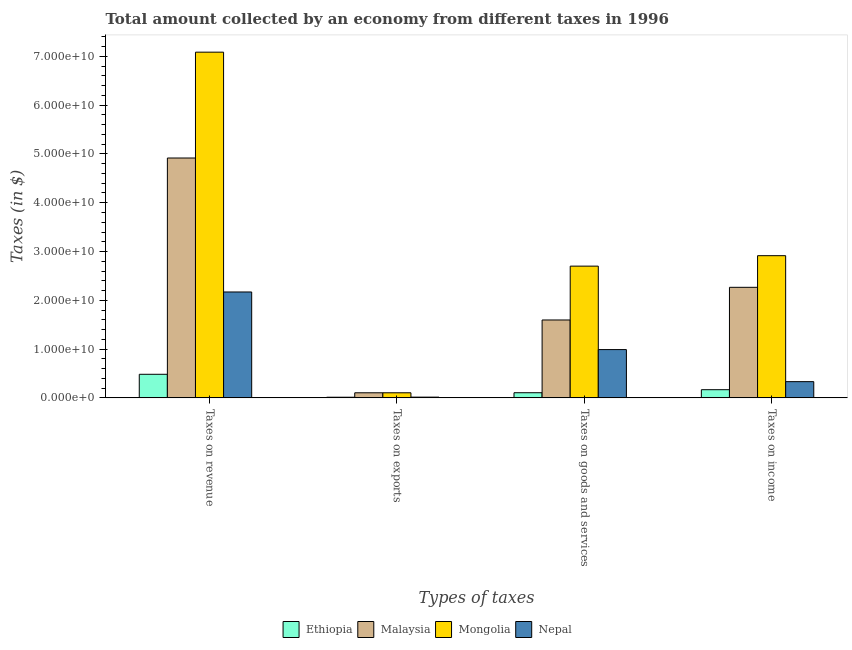Are the number of bars per tick equal to the number of legend labels?
Provide a short and direct response. Yes. How many bars are there on the 1st tick from the right?
Keep it short and to the point. 4. What is the label of the 4th group of bars from the left?
Provide a short and direct response. Taxes on income. What is the amount collected as tax on revenue in Nepal?
Provide a short and direct response. 2.17e+1. Across all countries, what is the maximum amount collected as tax on income?
Provide a short and direct response. 2.91e+1. Across all countries, what is the minimum amount collected as tax on revenue?
Provide a short and direct response. 4.84e+09. In which country was the amount collected as tax on goods maximum?
Your response must be concise. Mongolia. In which country was the amount collected as tax on income minimum?
Provide a short and direct response. Ethiopia. What is the total amount collected as tax on goods in the graph?
Keep it short and to the point. 5.39e+1. What is the difference between the amount collected as tax on exports in Mongolia and that in Ethiopia?
Ensure brevity in your answer.  9.12e+08. What is the difference between the amount collected as tax on exports in Nepal and the amount collected as tax on income in Malaysia?
Provide a succinct answer. -2.25e+1. What is the average amount collected as tax on goods per country?
Offer a terse response. 1.35e+1. What is the difference between the amount collected as tax on revenue and amount collected as tax on exports in Malaysia?
Make the answer very short. 4.81e+1. In how many countries, is the amount collected as tax on goods greater than 62000000000 $?
Offer a terse response. 0. What is the ratio of the amount collected as tax on exports in Ethiopia to that in Nepal?
Your answer should be compact. 0.87. Is the amount collected as tax on goods in Malaysia less than that in Nepal?
Offer a very short reply. No. What is the difference between the highest and the second highest amount collected as tax on revenue?
Provide a short and direct response. 2.17e+1. What is the difference between the highest and the lowest amount collected as tax on exports?
Your answer should be compact. 9.12e+08. In how many countries, is the amount collected as tax on goods greater than the average amount collected as tax on goods taken over all countries?
Make the answer very short. 2. What does the 4th bar from the left in Taxes on goods and services represents?
Offer a very short reply. Nepal. What does the 1st bar from the right in Taxes on revenue represents?
Make the answer very short. Nepal. How many bars are there?
Give a very brief answer. 16. Are all the bars in the graph horizontal?
Provide a short and direct response. No. How many countries are there in the graph?
Offer a terse response. 4. Are the values on the major ticks of Y-axis written in scientific E-notation?
Ensure brevity in your answer.  Yes. Does the graph contain any zero values?
Your answer should be very brief. No. Does the graph contain grids?
Offer a terse response. No. How many legend labels are there?
Your response must be concise. 4. How are the legend labels stacked?
Keep it short and to the point. Horizontal. What is the title of the graph?
Keep it short and to the point. Total amount collected by an economy from different taxes in 1996. What is the label or title of the X-axis?
Give a very brief answer. Types of taxes. What is the label or title of the Y-axis?
Your answer should be very brief. Taxes (in $). What is the Taxes (in $) of Ethiopia in Taxes on revenue?
Provide a succinct answer. 4.84e+09. What is the Taxes (in $) in Malaysia in Taxes on revenue?
Provide a short and direct response. 4.92e+1. What is the Taxes (in $) in Mongolia in Taxes on revenue?
Offer a terse response. 7.09e+1. What is the Taxes (in $) of Nepal in Taxes on revenue?
Make the answer very short. 2.17e+1. What is the Taxes (in $) in Ethiopia in Taxes on exports?
Your response must be concise. 1.31e+08. What is the Taxes (in $) in Malaysia in Taxes on exports?
Make the answer very short. 1.04e+09. What is the Taxes (in $) of Mongolia in Taxes on exports?
Your response must be concise. 1.04e+09. What is the Taxes (in $) in Nepal in Taxes on exports?
Ensure brevity in your answer.  1.50e+08. What is the Taxes (in $) in Ethiopia in Taxes on goods and services?
Your answer should be compact. 1.05e+09. What is the Taxes (in $) of Malaysia in Taxes on goods and services?
Your answer should be very brief. 1.60e+1. What is the Taxes (in $) in Mongolia in Taxes on goods and services?
Make the answer very short. 2.70e+1. What is the Taxes (in $) of Nepal in Taxes on goods and services?
Provide a short and direct response. 9.90e+09. What is the Taxes (in $) of Ethiopia in Taxes on income?
Provide a short and direct response. 1.68e+09. What is the Taxes (in $) of Malaysia in Taxes on income?
Give a very brief answer. 2.27e+1. What is the Taxes (in $) in Mongolia in Taxes on income?
Keep it short and to the point. 2.91e+1. What is the Taxes (in $) in Nepal in Taxes on income?
Keep it short and to the point. 3.33e+09. Across all Types of taxes, what is the maximum Taxes (in $) in Ethiopia?
Make the answer very short. 4.84e+09. Across all Types of taxes, what is the maximum Taxes (in $) in Malaysia?
Provide a succinct answer. 4.92e+1. Across all Types of taxes, what is the maximum Taxes (in $) of Mongolia?
Your answer should be very brief. 7.09e+1. Across all Types of taxes, what is the maximum Taxes (in $) of Nepal?
Keep it short and to the point. 2.17e+1. Across all Types of taxes, what is the minimum Taxes (in $) in Ethiopia?
Your answer should be compact. 1.31e+08. Across all Types of taxes, what is the minimum Taxes (in $) of Malaysia?
Offer a very short reply. 1.04e+09. Across all Types of taxes, what is the minimum Taxes (in $) in Mongolia?
Ensure brevity in your answer.  1.04e+09. Across all Types of taxes, what is the minimum Taxes (in $) in Nepal?
Your answer should be very brief. 1.50e+08. What is the total Taxes (in $) of Ethiopia in the graph?
Your answer should be compact. 7.70e+09. What is the total Taxes (in $) in Malaysia in the graph?
Ensure brevity in your answer.  8.88e+1. What is the total Taxes (in $) in Mongolia in the graph?
Offer a terse response. 1.28e+11. What is the total Taxes (in $) of Nepal in the graph?
Offer a terse response. 3.51e+1. What is the difference between the Taxes (in $) of Ethiopia in Taxes on revenue and that in Taxes on exports?
Keep it short and to the point. 4.70e+09. What is the difference between the Taxes (in $) in Malaysia in Taxes on revenue and that in Taxes on exports?
Keep it short and to the point. 4.81e+1. What is the difference between the Taxes (in $) in Mongolia in Taxes on revenue and that in Taxes on exports?
Keep it short and to the point. 6.98e+1. What is the difference between the Taxes (in $) of Nepal in Taxes on revenue and that in Taxes on exports?
Keep it short and to the point. 2.16e+1. What is the difference between the Taxes (in $) of Ethiopia in Taxes on revenue and that in Taxes on goods and services?
Your response must be concise. 3.78e+09. What is the difference between the Taxes (in $) of Malaysia in Taxes on revenue and that in Taxes on goods and services?
Your answer should be very brief. 3.32e+1. What is the difference between the Taxes (in $) of Mongolia in Taxes on revenue and that in Taxes on goods and services?
Ensure brevity in your answer.  4.39e+1. What is the difference between the Taxes (in $) in Nepal in Taxes on revenue and that in Taxes on goods and services?
Provide a short and direct response. 1.18e+1. What is the difference between the Taxes (in $) of Ethiopia in Taxes on revenue and that in Taxes on income?
Provide a succinct answer. 3.16e+09. What is the difference between the Taxes (in $) of Malaysia in Taxes on revenue and that in Taxes on income?
Your answer should be very brief. 2.65e+1. What is the difference between the Taxes (in $) in Mongolia in Taxes on revenue and that in Taxes on income?
Keep it short and to the point. 4.17e+1. What is the difference between the Taxes (in $) of Nepal in Taxes on revenue and that in Taxes on income?
Provide a short and direct response. 1.84e+1. What is the difference between the Taxes (in $) in Ethiopia in Taxes on exports and that in Taxes on goods and services?
Make the answer very short. -9.22e+08. What is the difference between the Taxes (in $) in Malaysia in Taxes on exports and that in Taxes on goods and services?
Make the answer very short. -1.49e+1. What is the difference between the Taxes (in $) of Mongolia in Taxes on exports and that in Taxes on goods and services?
Provide a succinct answer. -2.60e+1. What is the difference between the Taxes (in $) of Nepal in Taxes on exports and that in Taxes on goods and services?
Your answer should be compact. -9.75e+09. What is the difference between the Taxes (in $) of Ethiopia in Taxes on exports and that in Taxes on income?
Make the answer very short. -1.55e+09. What is the difference between the Taxes (in $) of Malaysia in Taxes on exports and that in Taxes on income?
Offer a terse response. -2.16e+1. What is the difference between the Taxes (in $) in Mongolia in Taxes on exports and that in Taxes on income?
Your response must be concise. -2.81e+1. What is the difference between the Taxes (in $) in Nepal in Taxes on exports and that in Taxes on income?
Ensure brevity in your answer.  -3.18e+09. What is the difference between the Taxes (in $) of Ethiopia in Taxes on goods and services and that in Taxes on income?
Ensure brevity in your answer.  -6.24e+08. What is the difference between the Taxes (in $) in Malaysia in Taxes on goods and services and that in Taxes on income?
Your answer should be compact. -6.70e+09. What is the difference between the Taxes (in $) in Mongolia in Taxes on goods and services and that in Taxes on income?
Your response must be concise. -2.14e+09. What is the difference between the Taxes (in $) of Nepal in Taxes on goods and services and that in Taxes on income?
Your response must be concise. 6.57e+09. What is the difference between the Taxes (in $) of Ethiopia in Taxes on revenue and the Taxes (in $) of Malaysia in Taxes on exports?
Offer a terse response. 3.79e+09. What is the difference between the Taxes (in $) of Ethiopia in Taxes on revenue and the Taxes (in $) of Mongolia in Taxes on exports?
Ensure brevity in your answer.  3.79e+09. What is the difference between the Taxes (in $) in Ethiopia in Taxes on revenue and the Taxes (in $) in Nepal in Taxes on exports?
Offer a very short reply. 4.69e+09. What is the difference between the Taxes (in $) in Malaysia in Taxes on revenue and the Taxes (in $) in Mongolia in Taxes on exports?
Give a very brief answer. 4.81e+1. What is the difference between the Taxes (in $) in Malaysia in Taxes on revenue and the Taxes (in $) in Nepal in Taxes on exports?
Give a very brief answer. 4.90e+1. What is the difference between the Taxes (in $) of Mongolia in Taxes on revenue and the Taxes (in $) of Nepal in Taxes on exports?
Provide a short and direct response. 7.07e+1. What is the difference between the Taxes (in $) in Ethiopia in Taxes on revenue and the Taxes (in $) in Malaysia in Taxes on goods and services?
Your answer should be very brief. -1.11e+1. What is the difference between the Taxes (in $) in Ethiopia in Taxes on revenue and the Taxes (in $) in Mongolia in Taxes on goods and services?
Your answer should be compact. -2.22e+1. What is the difference between the Taxes (in $) of Ethiopia in Taxes on revenue and the Taxes (in $) of Nepal in Taxes on goods and services?
Offer a terse response. -5.06e+09. What is the difference between the Taxes (in $) in Malaysia in Taxes on revenue and the Taxes (in $) in Mongolia in Taxes on goods and services?
Offer a very short reply. 2.22e+1. What is the difference between the Taxes (in $) in Malaysia in Taxes on revenue and the Taxes (in $) in Nepal in Taxes on goods and services?
Keep it short and to the point. 3.93e+1. What is the difference between the Taxes (in $) of Mongolia in Taxes on revenue and the Taxes (in $) of Nepal in Taxes on goods and services?
Keep it short and to the point. 6.10e+1. What is the difference between the Taxes (in $) of Ethiopia in Taxes on revenue and the Taxes (in $) of Malaysia in Taxes on income?
Keep it short and to the point. -1.78e+1. What is the difference between the Taxes (in $) in Ethiopia in Taxes on revenue and the Taxes (in $) in Mongolia in Taxes on income?
Offer a very short reply. -2.43e+1. What is the difference between the Taxes (in $) in Ethiopia in Taxes on revenue and the Taxes (in $) in Nepal in Taxes on income?
Your answer should be compact. 1.51e+09. What is the difference between the Taxes (in $) in Malaysia in Taxes on revenue and the Taxes (in $) in Mongolia in Taxes on income?
Your answer should be very brief. 2.00e+1. What is the difference between the Taxes (in $) in Malaysia in Taxes on revenue and the Taxes (in $) in Nepal in Taxes on income?
Your answer should be very brief. 4.58e+1. What is the difference between the Taxes (in $) of Mongolia in Taxes on revenue and the Taxes (in $) of Nepal in Taxes on income?
Offer a terse response. 6.75e+1. What is the difference between the Taxes (in $) of Ethiopia in Taxes on exports and the Taxes (in $) of Malaysia in Taxes on goods and services?
Ensure brevity in your answer.  -1.58e+1. What is the difference between the Taxes (in $) in Ethiopia in Taxes on exports and the Taxes (in $) in Mongolia in Taxes on goods and services?
Provide a succinct answer. -2.69e+1. What is the difference between the Taxes (in $) in Ethiopia in Taxes on exports and the Taxes (in $) in Nepal in Taxes on goods and services?
Your response must be concise. -9.77e+09. What is the difference between the Taxes (in $) in Malaysia in Taxes on exports and the Taxes (in $) in Mongolia in Taxes on goods and services?
Make the answer very short. -2.60e+1. What is the difference between the Taxes (in $) of Malaysia in Taxes on exports and the Taxes (in $) of Nepal in Taxes on goods and services?
Offer a very short reply. -8.86e+09. What is the difference between the Taxes (in $) of Mongolia in Taxes on exports and the Taxes (in $) of Nepal in Taxes on goods and services?
Ensure brevity in your answer.  -8.86e+09. What is the difference between the Taxes (in $) in Ethiopia in Taxes on exports and the Taxes (in $) in Malaysia in Taxes on income?
Give a very brief answer. -2.25e+1. What is the difference between the Taxes (in $) in Ethiopia in Taxes on exports and the Taxes (in $) in Mongolia in Taxes on income?
Give a very brief answer. -2.90e+1. What is the difference between the Taxes (in $) of Ethiopia in Taxes on exports and the Taxes (in $) of Nepal in Taxes on income?
Provide a succinct answer. -3.20e+09. What is the difference between the Taxes (in $) in Malaysia in Taxes on exports and the Taxes (in $) in Mongolia in Taxes on income?
Your response must be concise. -2.81e+1. What is the difference between the Taxes (in $) in Malaysia in Taxes on exports and the Taxes (in $) in Nepal in Taxes on income?
Offer a terse response. -2.28e+09. What is the difference between the Taxes (in $) of Mongolia in Taxes on exports and the Taxes (in $) of Nepal in Taxes on income?
Your response must be concise. -2.28e+09. What is the difference between the Taxes (in $) of Ethiopia in Taxes on goods and services and the Taxes (in $) of Malaysia in Taxes on income?
Provide a short and direct response. -2.16e+1. What is the difference between the Taxes (in $) of Ethiopia in Taxes on goods and services and the Taxes (in $) of Mongolia in Taxes on income?
Your response must be concise. -2.81e+1. What is the difference between the Taxes (in $) in Ethiopia in Taxes on goods and services and the Taxes (in $) in Nepal in Taxes on income?
Offer a very short reply. -2.27e+09. What is the difference between the Taxes (in $) in Malaysia in Taxes on goods and services and the Taxes (in $) in Mongolia in Taxes on income?
Make the answer very short. -1.32e+1. What is the difference between the Taxes (in $) in Malaysia in Taxes on goods and services and the Taxes (in $) in Nepal in Taxes on income?
Provide a succinct answer. 1.26e+1. What is the difference between the Taxes (in $) in Mongolia in Taxes on goods and services and the Taxes (in $) in Nepal in Taxes on income?
Make the answer very short. 2.37e+1. What is the average Taxes (in $) in Ethiopia per Types of taxes?
Give a very brief answer. 1.92e+09. What is the average Taxes (in $) in Malaysia per Types of taxes?
Ensure brevity in your answer.  2.22e+1. What is the average Taxes (in $) in Mongolia per Types of taxes?
Make the answer very short. 3.20e+1. What is the average Taxes (in $) in Nepal per Types of taxes?
Your answer should be very brief. 8.77e+09. What is the difference between the Taxes (in $) in Ethiopia and Taxes (in $) in Malaysia in Taxes on revenue?
Make the answer very short. -4.43e+1. What is the difference between the Taxes (in $) of Ethiopia and Taxes (in $) of Mongolia in Taxes on revenue?
Offer a very short reply. -6.60e+1. What is the difference between the Taxes (in $) in Ethiopia and Taxes (in $) in Nepal in Taxes on revenue?
Ensure brevity in your answer.  -1.69e+1. What is the difference between the Taxes (in $) in Malaysia and Taxes (in $) in Mongolia in Taxes on revenue?
Make the answer very short. -2.17e+1. What is the difference between the Taxes (in $) of Malaysia and Taxes (in $) of Nepal in Taxes on revenue?
Provide a succinct answer. 2.75e+1. What is the difference between the Taxes (in $) of Mongolia and Taxes (in $) of Nepal in Taxes on revenue?
Give a very brief answer. 4.92e+1. What is the difference between the Taxes (in $) of Ethiopia and Taxes (in $) of Malaysia in Taxes on exports?
Provide a short and direct response. -9.10e+08. What is the difference between the Taxes (in $) in Ethiopia and Taxes (in $) in Mongolia in Taxes on exports?
Offer a very short reply. -9.12e+08. What is the difference between the Taxes (in $) of Ethiopia and Taxes (in $) of Nepal in Taxes on exports?
Your answer should be compact. -1.90e+07. What is the difference between the Taxes (in $) in Malaysia and Taxes (in $) in Nepal in Taxes on exports?
Your response must be concise. 8.91e+08. What is the difference between the Taxes (in $) in Mongolia and Taxes (in $) in Nepal in Taxes on exports?
Make the answer very short. 8.93e+08. What is the difference between the Taxes (in $) of Ethiopia and Taxes (in $) of Malaysia in Taxes on goods and services?
Offer a very short reply. -1.49e+1. What is the difference between the Taxes (in $) of Ethiopia and Taxes (in $) of Mongolia in Taxes on goods and services?
Offer a terse response. -2.60e+1. What is the difference between the Taxes (in $) of Ethiopia and Taxes (in $) of Nepal in Taxes on goods and services?
Keep it short and to the point. -8.85e+09. What is the difference between the Taxes (in $) of Malaysia and Taxes (in $) of Mongolia in Taxes on goods and services?
Offer a terse response. -1.10e+1. What is the difference between the Taxes (in $) in Malaysia and Taxes (in $) in Nepal in Taxes on goods and services?
Provide a succinct answer. 6.07e+09. What is the difference between the Taxes (in $) of Mongolia and Taxes (in $) of Nepal in Taxes on goods and services?
Your answer should be very brief. 1.71e+1. What is the difference between the Taxes (in $) in Ethiopia and Taxes (in $) in Malaysia in Taxes on income?
Provide a short and direct response. -2.10e+1. What is the difference between the Taxes (in $) in Ethiopia and Taxes (in $) in Mongolia in Taxes on income?
Your answer should be compact. -2.75e+1. What is the difference between the Taxes (in $) of Ethiopia and Taxes (in $) of Nepal in Taxes on income?
Offer a terse response. -1.65e+09. What is the difference between the Taxes (in $) of Malaysia and Taxes (in $) of Mongolia in Taxes on income?
Provide a succinct answer. -6.49e+09. What is the difference between the Taxes (in $) in Malaysia and Taxes (in $) in Nepal in Taxes on income?
Your answer should be very brief. 1.93e+1. What is the difference between the Taxes (in $) of Mongolia and Taxes (in $) of Nepal in Taxes on income?
Provide a succinct answer. 2.58e+1. What is the ratio of the Taxes (in $) in Ethiopia in Taxes on revenue to that in Taxes on exports?
Offer a terse response. 36.91. What is the ratio of the Taxes (in $) of Malaysia in Taxes on revenue to that in Taxes on exports?
Keep it short and to the point. 47.23. What is the ratio of the Taxes (in $) of Mongolia in Taxes on revenue to that in Taxes on exports?
Offer a very short reply. 67.94. What is the ratio of the Taxes (in $) in Nepal in Taxes on revenue to that in Taxes on exports?
Your response must be concise. 144.7. What is the ratio of the Taxes (in $) in Ethiopia in Taxes on revenue to that in Taxes on goods and services?
Offer a very short reply. 4.59. What is the ratio of the Taxes (in $) of Malaysia in Taxes on revenue to that in Taxes on goods and services?
Your answer should be compact. 3.08. What is the ratio of the Taxes (in $) of Mongolia in Taxes on revenue to that in Taxes on goods and services?
Provide a succinct answer. 2.62. What is the ratio of the Taxes (in $) of Nepal in Taxes on revenue to that in Taxes on goods and services?
Offer a very short reply. 2.19. What is the ratio of the Taxes (in $) in Ethiopia in Taxes on revenue to that in Taxes on income?
Your response must be concise. 2.88. What is the ratio of the Taxes (in $) of Malaysia in Taxes on revenue to that in Taxes on income?
Your answer should be compact. 2.17. What is the ratio of the Taxes (in $) in Mongolia in Taxes on revenue to that in Taxes on income?
Offer a very short reply. 2.43. What is the ratio of the Taxes (in $) of Nepal in Taxes on revenue to that in Taxes on income?
Offer a terse response. 6.53. What is the ratio of the Taxes (in $) in Ethiopia in Taxes on exports to that in Taxes on goods and services?
Your response must be concise. 0.12. What is the ratio of the Taxes (in $) of Malaysia in Taxes on exports to that in Taxes on goods and services?
Keep it short and to the point. 0.07. What is the ratio of the Taxes (in $) in Mongolia in Taxes on exports to that in Taxes on goods and services?
Provide a short and direct response. 0.04. What is the ratio of the Taxes (in $) of Nepal in Taxes on exports to that in Taxes on goods and services?
Your answer should be compact. 0.02. What is the ratio of the Taxes (in $) in Ethiopia in Taxes on exports to that in Taxes on income?
Your answer should be compact. 0.08. What is the ratio of the Taxes (in $) in Malaysia in Taxes on exports to that in Taxes on income?
Your answer should be compact. 0.05. What is the ratio of the Taxes (in $) of Mongolia in Taxes on exports to that in Taxes on income?
Make the answer very short. 0.04. What is the ratio of the Taxes (in $) of Nepal in Taxes on exports to that in Taxes on income?
Make the answer very short. 0.05. What is the ratio of the Taxes (in $) of Ethiopia in Taxes on goods and services to that in Taxes on income?
Make the answer very short. 0.63. What is the ratio of the Taxes (in $) of Malaysia in Taxes on goods and services to that in Taxes on income?
Your answer should be compact. 0.7. What is the ratio of the Taxes (in $) of Mongolia in Taxes on goods and services to that in Taxes on income?
Make the answer very short. 0.93. What is the ratio of the Taxes (in $) in Nepal in Taxes on goods and services to that in Taxes on income?
Provide a succinct answer. 2.98. What is the difference between the highest and the second highest Taxes (in $) of Ethiopia?
Your answer should be compact. 3.16e+09. What is the difference between the highest and the second highest Taxes (in $) in Malaysia?
Offer a very short reply. 2.65e+1. What is the difference between the highest and the second highest Taxes (in $) of Mongolia?
Offer a very short reply. 4.17e+1. What is the difference between the highest and the second highest Taxes (in $) in Nepal?
Give a very brief answer. 1.18e+1. What is the difference between the highest and the lowest Taxes (in $) in Ethiopia?
Your answer should be very brief. 4.70e+09. What is the difference between the highest and the lowest Taxes (in $) of Malaysia?
Your response must be concise. 4.81e+1. What is the difference between the highest and the lowest Taxes (in $) of Mongolia?
Your answer should be very brief. 6.98e+1. What is the difference between the highest and the lowest Taxes (in $) of Nepal?
Make the answer very short. 2.16e+1. 